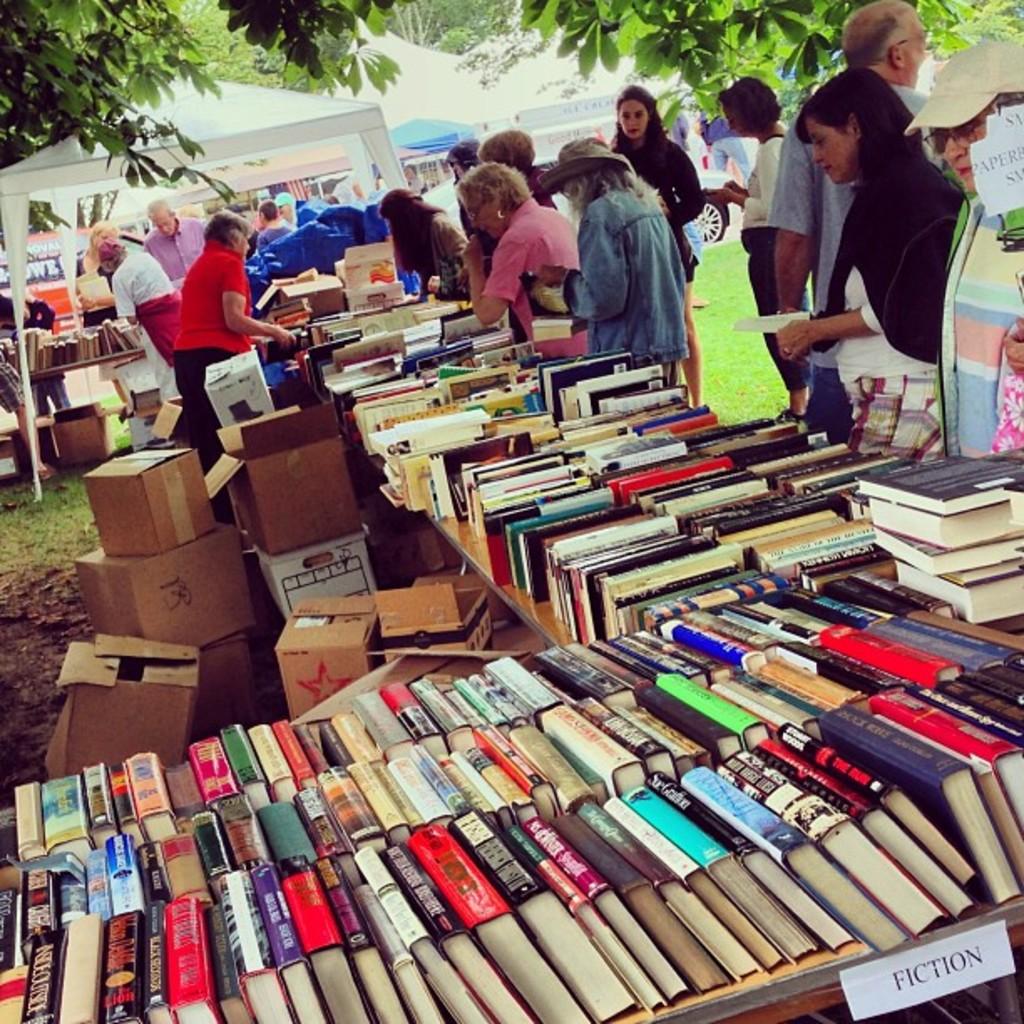What kind of books are in the nearby section?
Offer a very short reply. Fiction. 